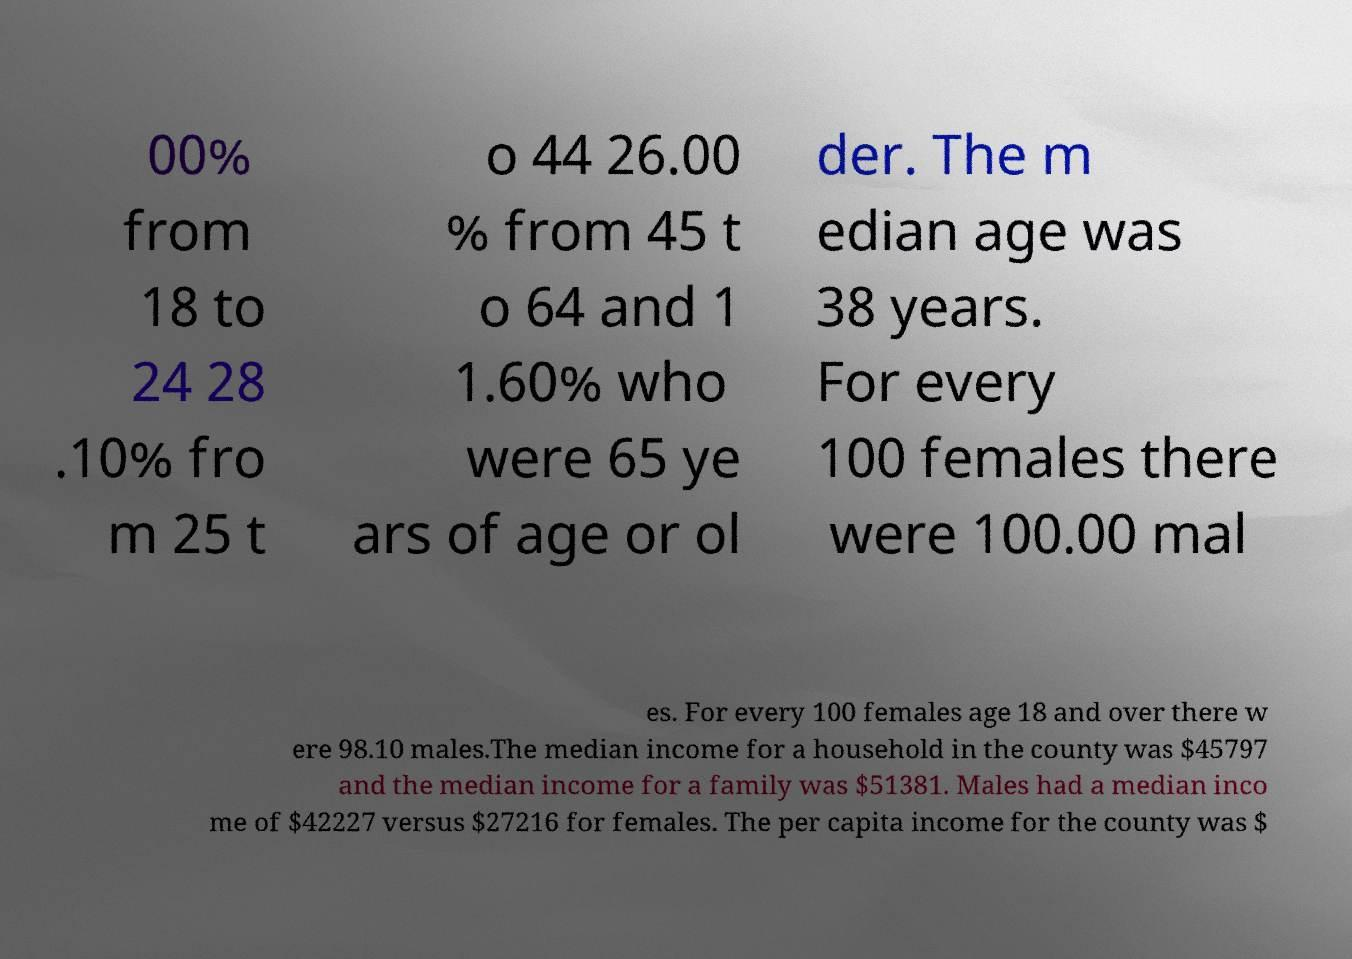What messages or text are displayed in this image? I need them in a readable, typed format. 00% from 18 to 24 28 .10% fro m 25 t o 44 26.00 % from 45 t o 64 and 1 1.60% who were 65 ye ars of age or ol der. The m edian age was 38 years. For every 100 females there were 100.00 mal es. For every 100 females age 18 and over there w ere 98.10 males.The median income for a household in the county was $45797 and the median income for a family was $51381. Males had a median inco me of $42227 versus $27216 for females. The per capita income for the county was $ 